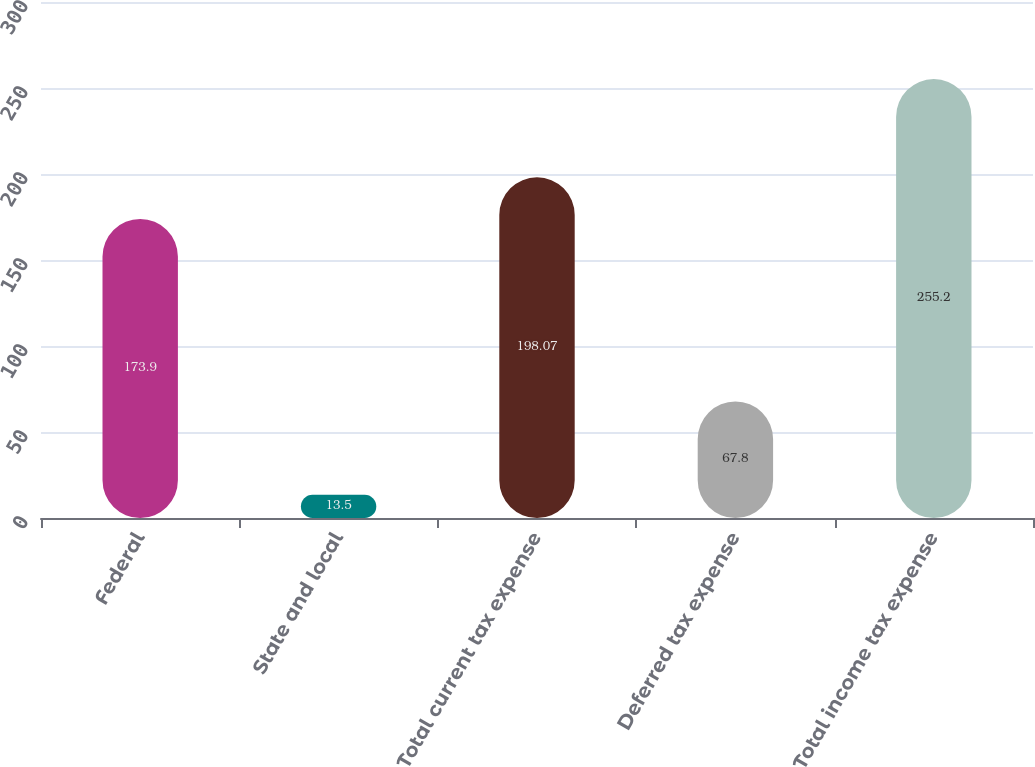Convert chart to OTSL. <chart><loc_0><loc_0><loc_500><loc_500><bar_chart><fcel>Federal<fcel>State and local<fcel>Total current tax expense<fcel>Deferred tax expense<fcel>Total income tax expense<nl><fcel>173.9<fcel>13.5<fcel>198.07<fcel>67.8<fcel>255.2<nl></chart> 